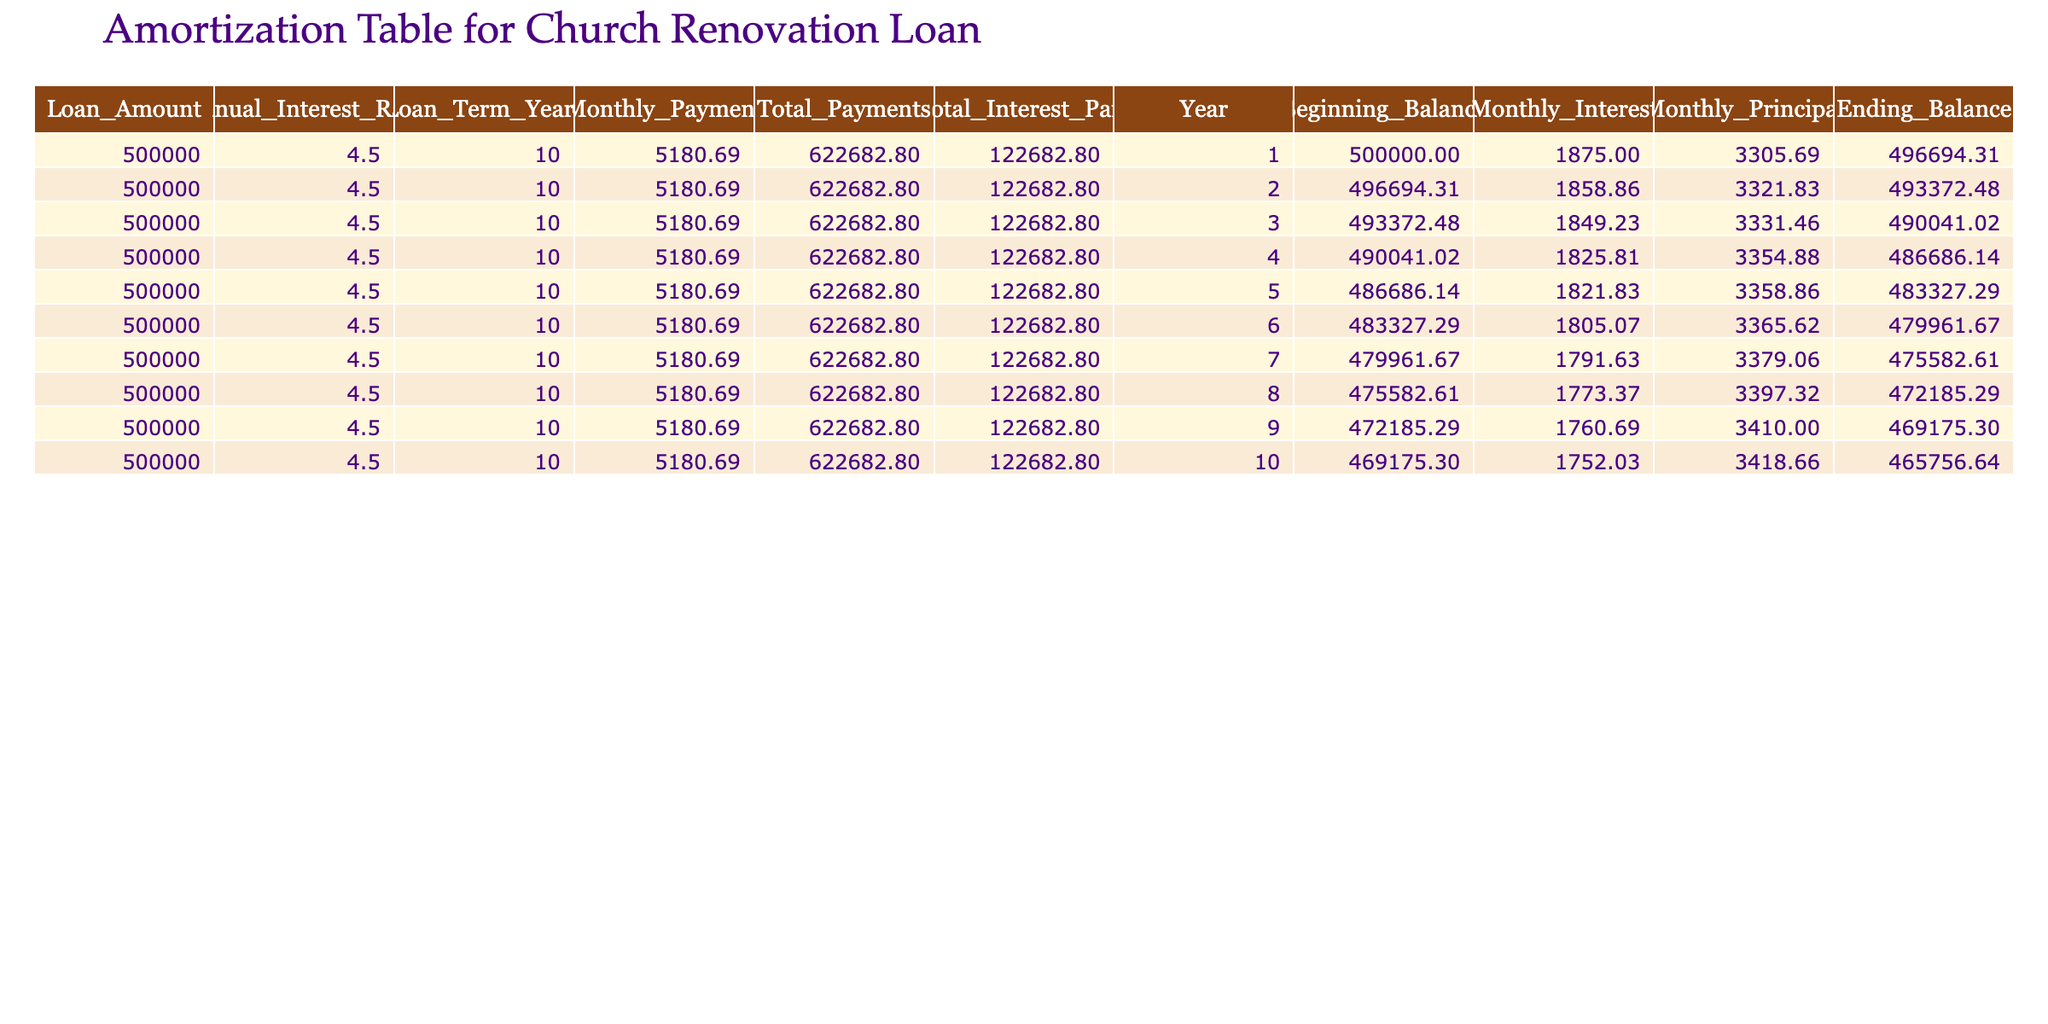What was the monthly payment for the church renovation loan? The monthly payment is listed in the first row of the table under the "Monthly_Payment" column, which shows 5180.69.
Answer: 5180.69 How much total interest will be paid over the entire loan term? The total interest paid is given in the "Total_Interest_Paid" column in the first row, which indicates a total of 122682.80.
Answer: 122682.80 What is the beginning balance after the first year? The beginning balance at the end of the first year is listed in the first row under the "Beginning_Balance" column, showing 500000.00.
Answer: 500000.00 For how many years will the church be making payments? The loan term is specified in the table under "Loan_Term_Years," which shows 10 years.
Answer: 10 years What was the monthly principal paid in the fifth year? To find the monthly principal at year five, we look at the "Monthly_Principal" column in the row corresponding to year five, which lists 3358.86.
Answer: 3358.86 Is the ending balance after the tenth year lower than the initial loan amount? We look at the "Ending_Balance" for the tenth year, which indicates 465756.64, and compare it to the initial loan amount of 500000. The ending balance is lower.
Answer: Yes What is the average monthly principal paid over the first five years? We sum the monthly principal payments for the first five years: (3305.69 + 3321.83 + 3331.46 + 3354.88 + 3358.86) = 16644.72. Dividing by 5 gives an average of 3328.94.
Answer: 3328.94 How much total payment is made in the second year? The total payment for the second year is in the "Total_Payments" column for year two, which shows 622682.80. This value is the same across all years due to the fixed payment structure.
Answer: 622682.80 How does the monthly interest change from the first year to the fifth year? The monthly interest at year one is recorded as 1875.00, while the fifth year's monthly interest is 1821.83. The change in interest is 1875.00 - 1821.83 = 53.17, indicating a decrease.
Answer: Decrease by 53.17 